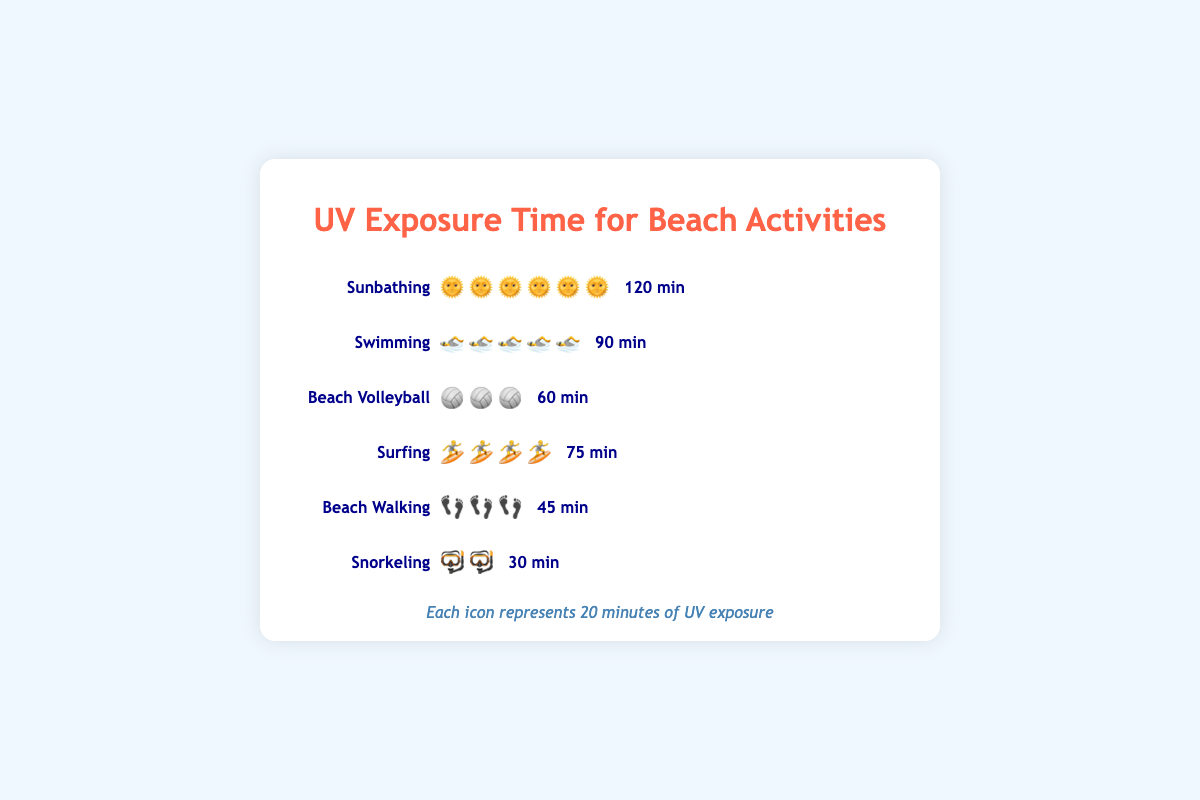What is the total UV exposure time for all the activities combined? To get the total UV exposure time, we sum the UV exposure times for all activities: Sunbathing (120), Swimming (90), Beach Volleyball (60), Surfing (75), Beach Walking (45), Snorkeling (30). The total is 120 + 90 + 60 + 75 + 45 + 30.
Answer: 420 minutes Which activity has the highest UV exposure time, and what is that time? Comparing the UV exposure times: Sunbathing (120), Swimming (90), Beach Volleyball (60), Surfing (75), Beach Walking (45), Snorkeling (30), we see that Sunbathing has the highest UV exposure time.
Answer: Sunbathing, 120 minutes How many minutes of UV exposure does Beach Volleyball have more than Beach Walking? Subtract the UV exposure time of Beach Walking (45) from that of Beach Volleyball (60). 60 - 45 gives the difference.
Answer: 15 minutes What is the average UV exposure time across all activities? Sum the UV exposure times for all activities (420 minutes) and divide by the number of activities (6). 420 / 6 equals 70.
Answer: 70 minutes Which activities have a UV exposure time greater than Snorkeling? Compare the UV exposure times of Snorkeling (30 minutes) with other activities: Sunbathing (120), Swimming (90), Beach Volleyball (60), Surfing (75), Beach Walking (45). All except Snorkeling have a greater exposure time.
Answer: Sunbathing, Swimming, Beach Volleyball, Surfing, Beach Walking How much less UV exposure time does Surfing have compared to Sunbathing? Subtract the UV exposure time of Surfing (75) from that of Sunbathing (120). 120 - 75 gives the difference.
Answer: 45 minutes If someone spends 1 hour on Beach Walking, how many more minutes do they need to spend Snorkeling to match that UV exposure? 1 hour equals 60 minutes. UV exposure time for Beach Walking is 45 minutes. Subtract 45 from 60 to get the additional time needed for Snorkeling. 60 - 30 is the total needed minus Snorkeling.
Answer: 15 minutes Which activity has the shortest UV exposure time, and what is that time? The activity with the shortest UV exposure time can be determined by comparing all the exposure times. Snorkeling has 30 minutes, which is the least.
Answer: Snorkeling, 30 minutes What is the difference in UV exposure time between the activity with the highest exposure and the activity with the lowest exposure? Subtract the UV exposure time of Snorkeling (30 minutes) from Sunbathing (120 minutes). 120 - 30 gives the difference.
Answer: 90 minutes 